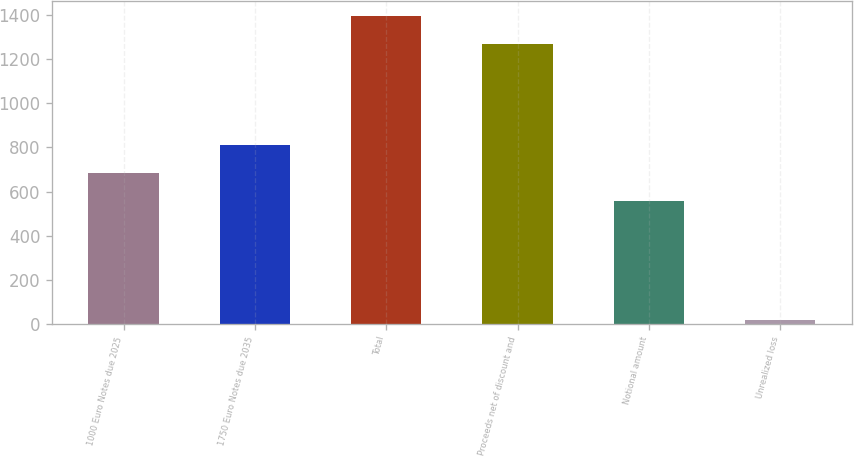<chart> <loc_0><loc_0><loc_500><loc_500><bar_chart><fcel>1000 Euro Notes due 2025<fcel>1750 Euro Notes due 2035<fcel>Total<fcel>Proceeds net of discount and<fcel>Notional amount<fcel>Unrealized loss<nl><fcel>685.8<fcel>812.6<fcel>1394.8<fcel>1268<fcel>559<fcel>18<nl></chart> 